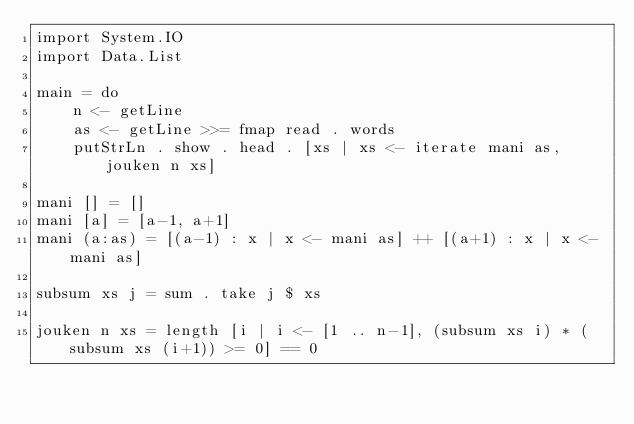Convert code to text. <code><loc_0><loc_0><loc_500><loc_500><_Haskell_>import System.IO
import Data.List

main = do
	n <- getLine
	as <- getLine >>= fmap read . words
	putStrLn . show . head . [xs | xs <- iterate mani as, jouken n xs] 

mani [] = []
mani [a] = [a-1, a+1]
mani (a:as) = [(a-1) : x | x <- mani as] ++ [(a+1) : x | x <- mani as]

subsum xs j = sum . take j $ xs

jouken n xs = length [i | i <- [1 .. n-1], (subsum xs i) * (subsum xs (i+1)) >= 0] == 0</code> 